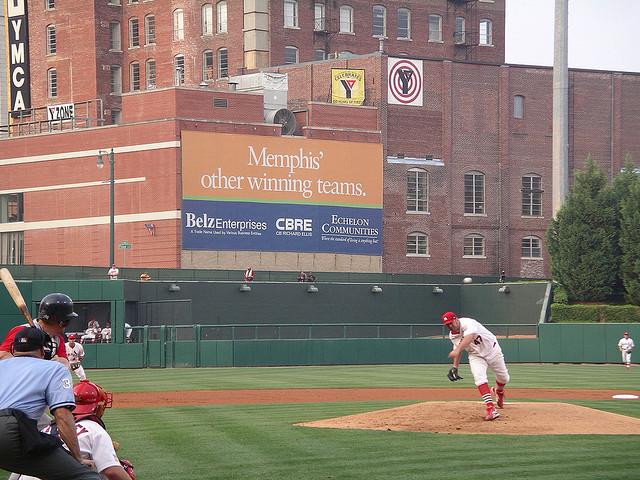What business is behind the baseball field?
Keep it brief. Ymca. Where are they?
Keep it brief. Memphis. What song by the Village people is also one of the signs in the picture?
Concise answer only. Ymca. 